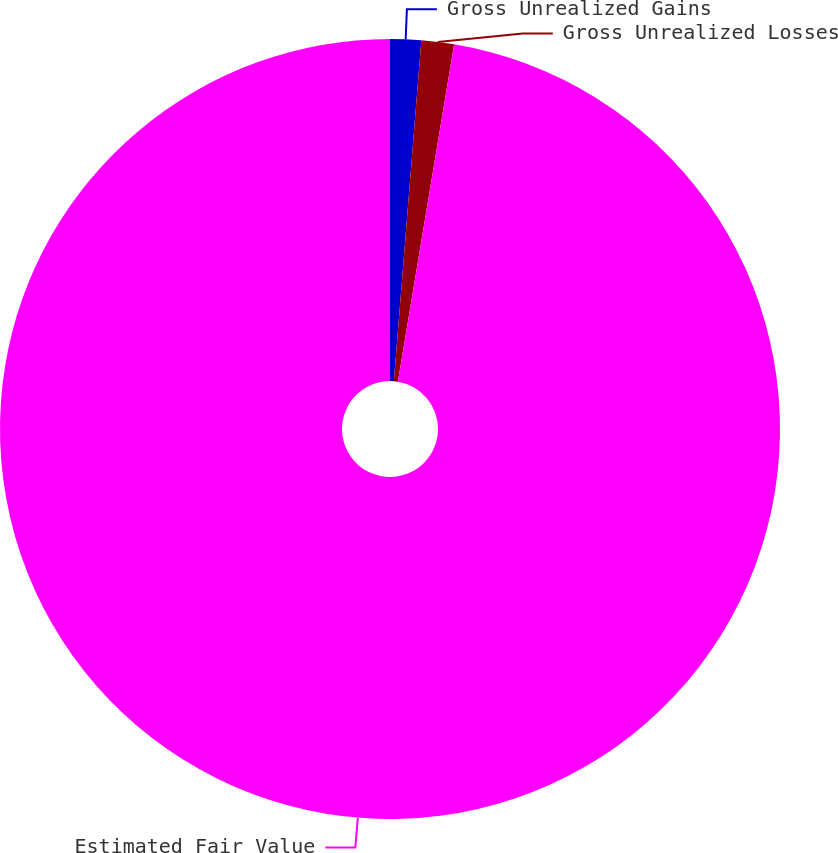Convert chart. <chart><loc_0><loc_0><loc_500><loc_500><pie_chart><fcel>Gross Unrealized Gains<fcel>Gross Unrealized Losses<fcel>Estimated Fair Value<nl><fcel>1.28%<fcel>1.35%<fcel>97.37%<nl></chart> 